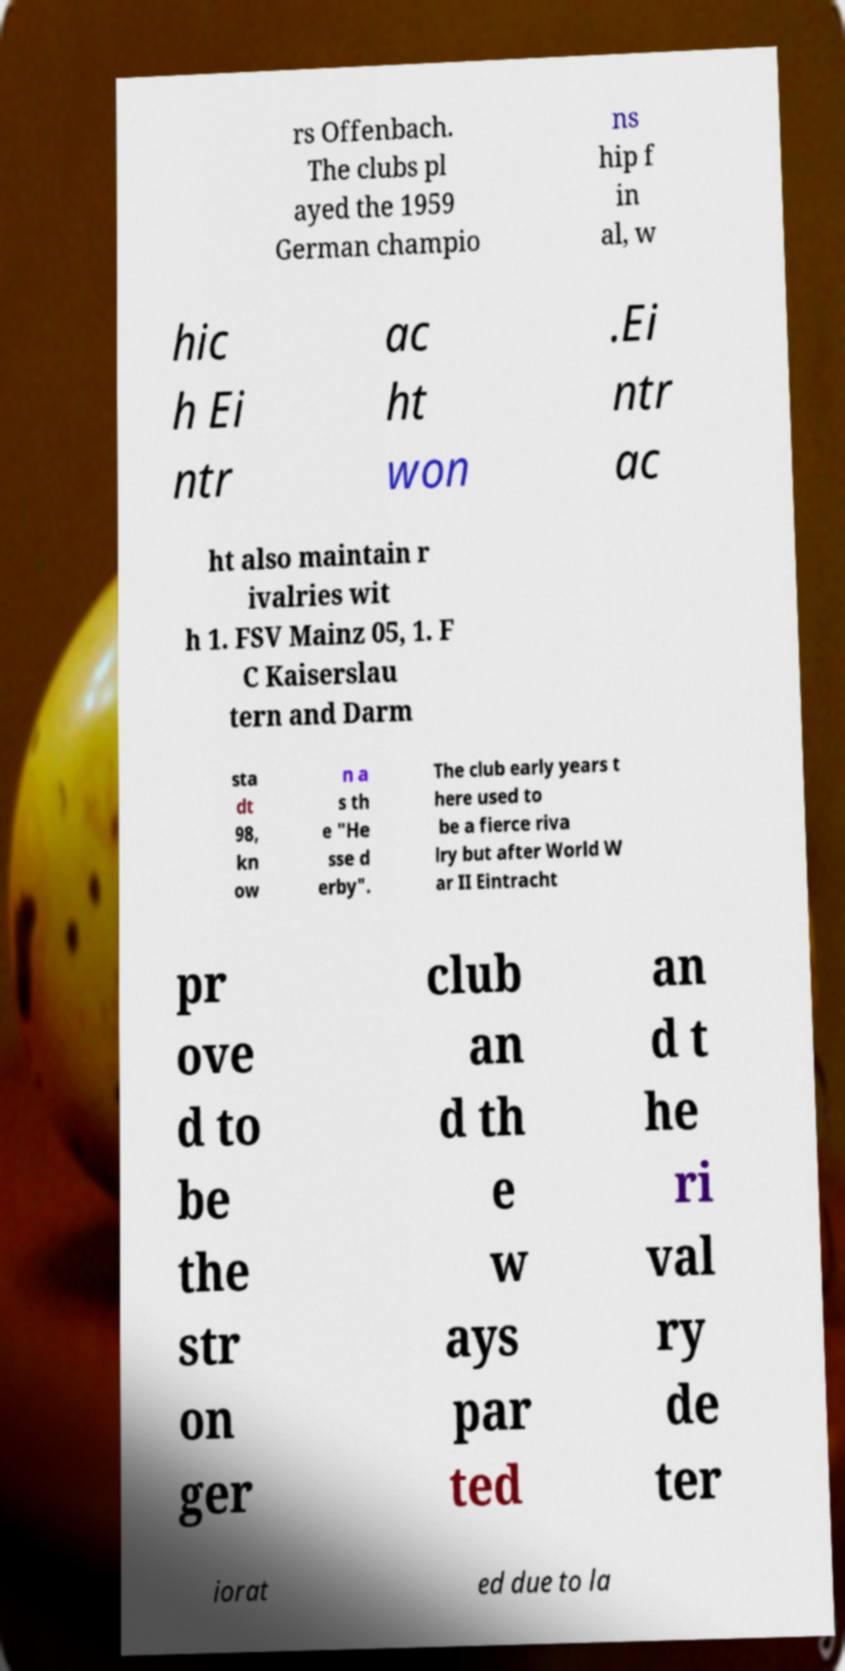Can you accurately transcribe the text from the provided image for me? rs Offenbach. The clubs pl ayed the 1959 German champio ns hip f in al, w hic h Ei ntr ac ht won .Ei ntr ac ht also maintain r ivalries wit h 1. FSV Mainz 05, 1. F C Kaiserslau tern and Darm sta dt 98, kn ow n a s th e "He sse d erby". The club early years t here used to be a fierce riva lry but after World W ar II Eintracht pr ove d to be the str on ger club an d th e w ays par ted an d t he ri val ry de ter iorat ed due to la 